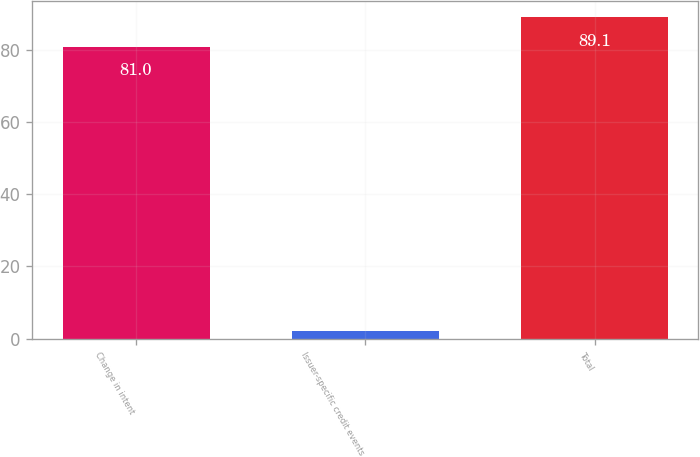Convert chart to OTSL. <chart><loc_0><loc_0><loc_500><loc_500><bar_chart><fcel>Change in intent<fcel>Issuer-specific credit events<fcel>Total<nl><fcel>81<fcel>2<fcel>89.1<nl></chart> 